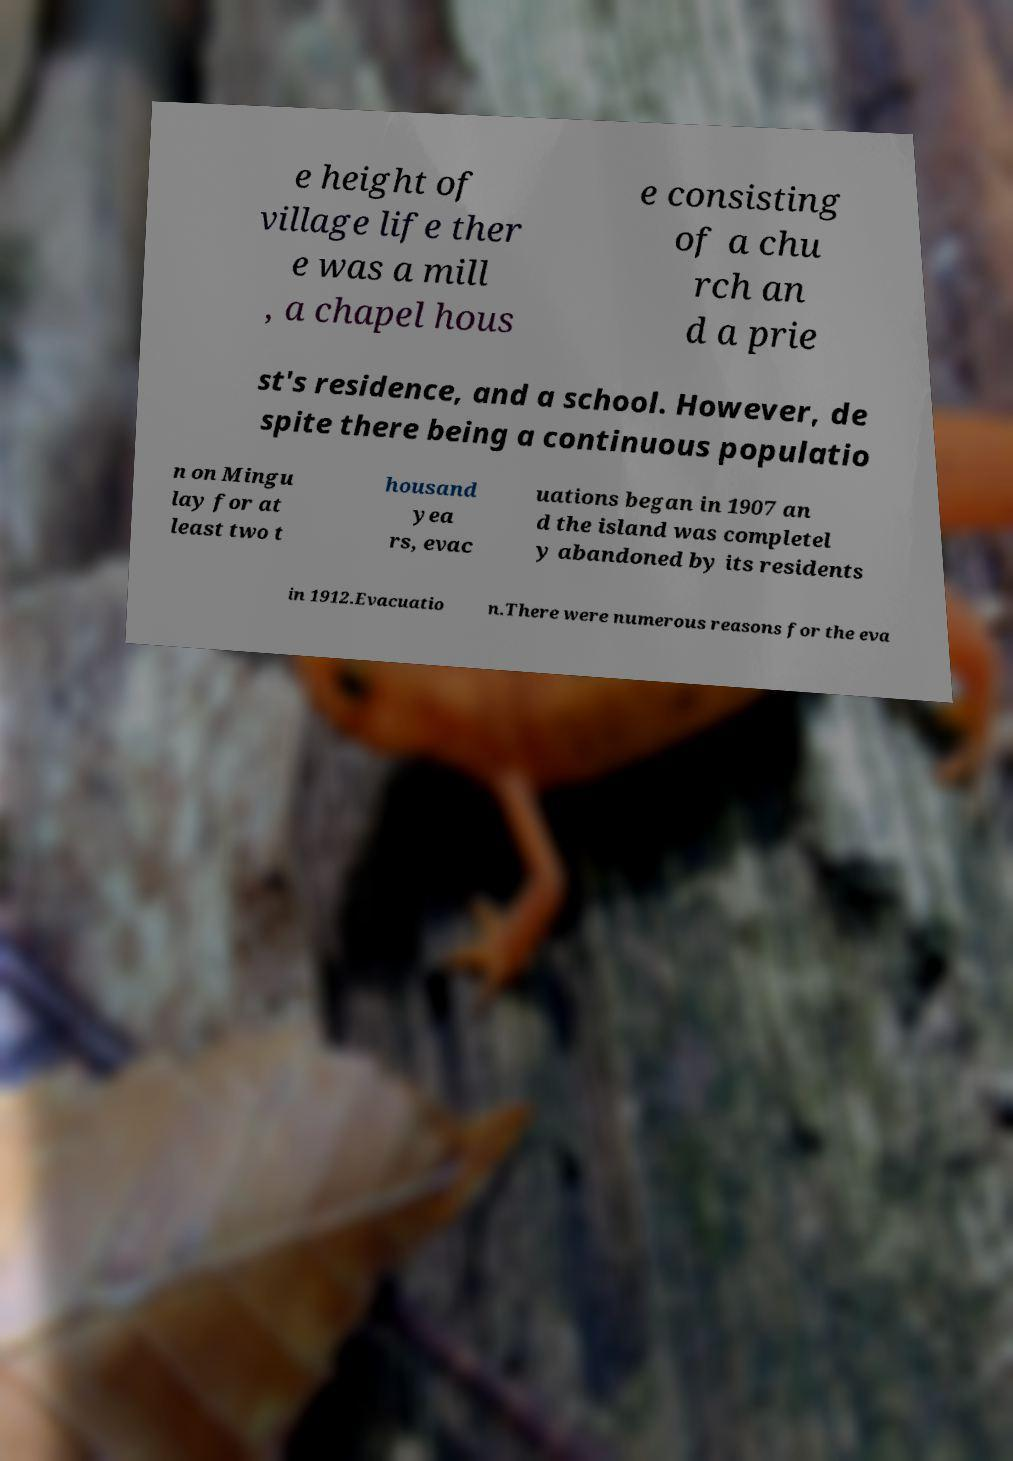What messages or text are displayed in this image? I need them in a readable, typed format. e height of village life ther e was a mill , a chapel hous e consisting of a chu rch an d a prie st's residence, and a school. However, de spite there being a continuous populatio n on Mingu lay for at least two t housand yea rs, evac uations began in 1907 an d the island was completel y abandoned by its residents in 1912.Evacuatio n.There were numerous reasons for the eva 